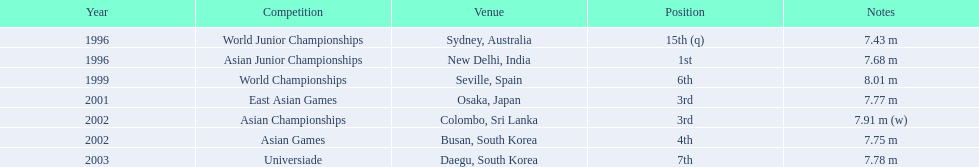What are all the events? World Junior Championships, Asian Junior Championships, World Championships, East Asian Games, Asian Championships, Asian Games, Universiade. What were his placements in these events? 15th (q), 1st, 6th, 3rd, 3rd, 4th, 7th. And in which event did he attain 1st place? Asian Junior Championships. 